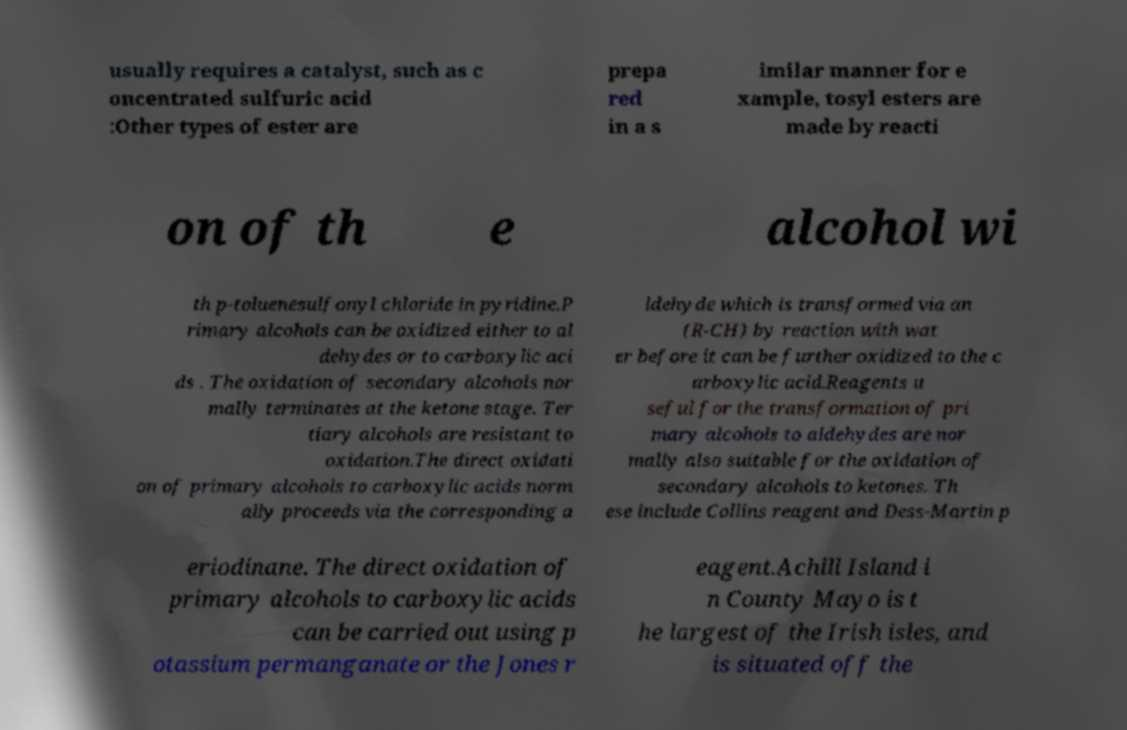Please identify and transcribe the text found in this image. usually requires a catalyst, such as c oncentrated sulfuric acid :Other types of ester are prepa red in a s imilar manner for e xample, tosyl esters are made by reacti on of th e alcohol wi th p-toluenesulfonyl chloride in pyridine.P rimary alcohols can be oxidized either to al dehydes or to carboxylic aci ds . The oxidation of secondary alcohols nor mally terminates at the ketone stage. Ter tiary alcohols are resistant to oxidation.The direct oxidati on of primary alcohols to carboxylic acids norm ally proceeds via the corresponding a ldehyde which is transformed via an (R-CH) by reaction with wat er before it can be further oxidized to the c arboxylic acid.Reagents u seful for the transformation of pri mary alcohols to aldehydes are nor mally also suitable for the oxidation of secondary alcohols to ketones. Th ese include Collins reagent and Dess-Martin p eriodinane. The direct oxidation of primary alcohols to carboxylic acids can be carried out using p otassium permanganate or the Jones r eagent.Achill Island i n County Mayo is t he largest of the Irish isles, and is situated off the 